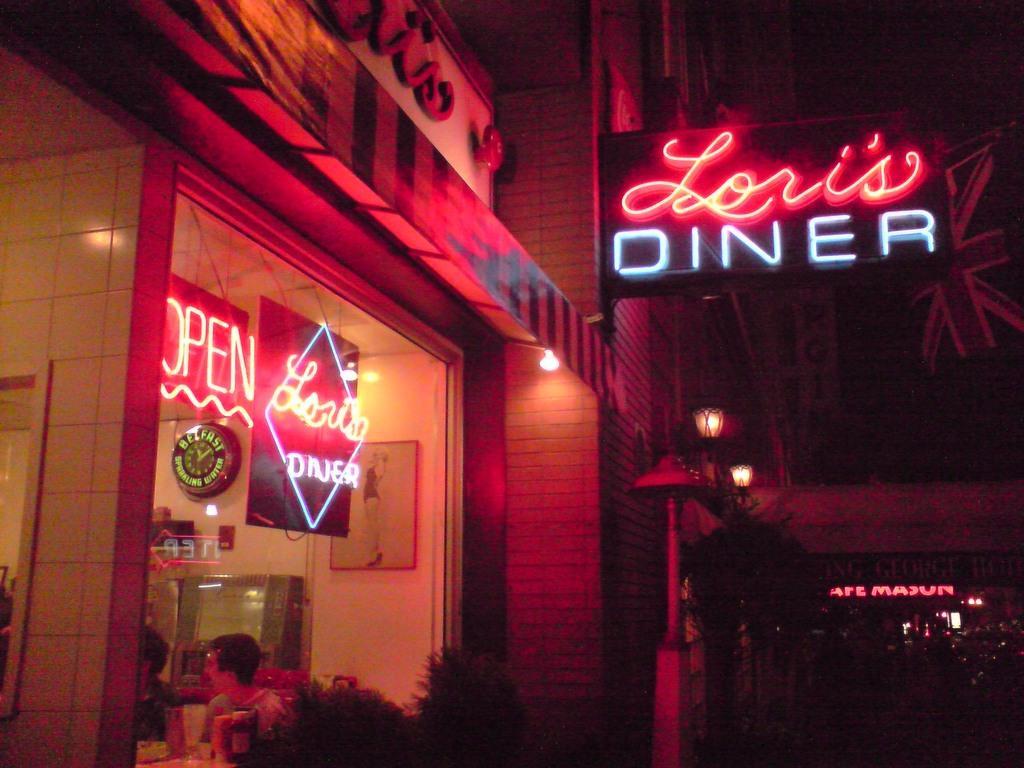Could you give a brief overview of what you see in this image? In this picture there is a building. There is a board fixed to the wall on which we can observe red and white color lights. We can observe two persons sitting inside this building. There are two boards. We can observe some plants. In the background it is dark. 